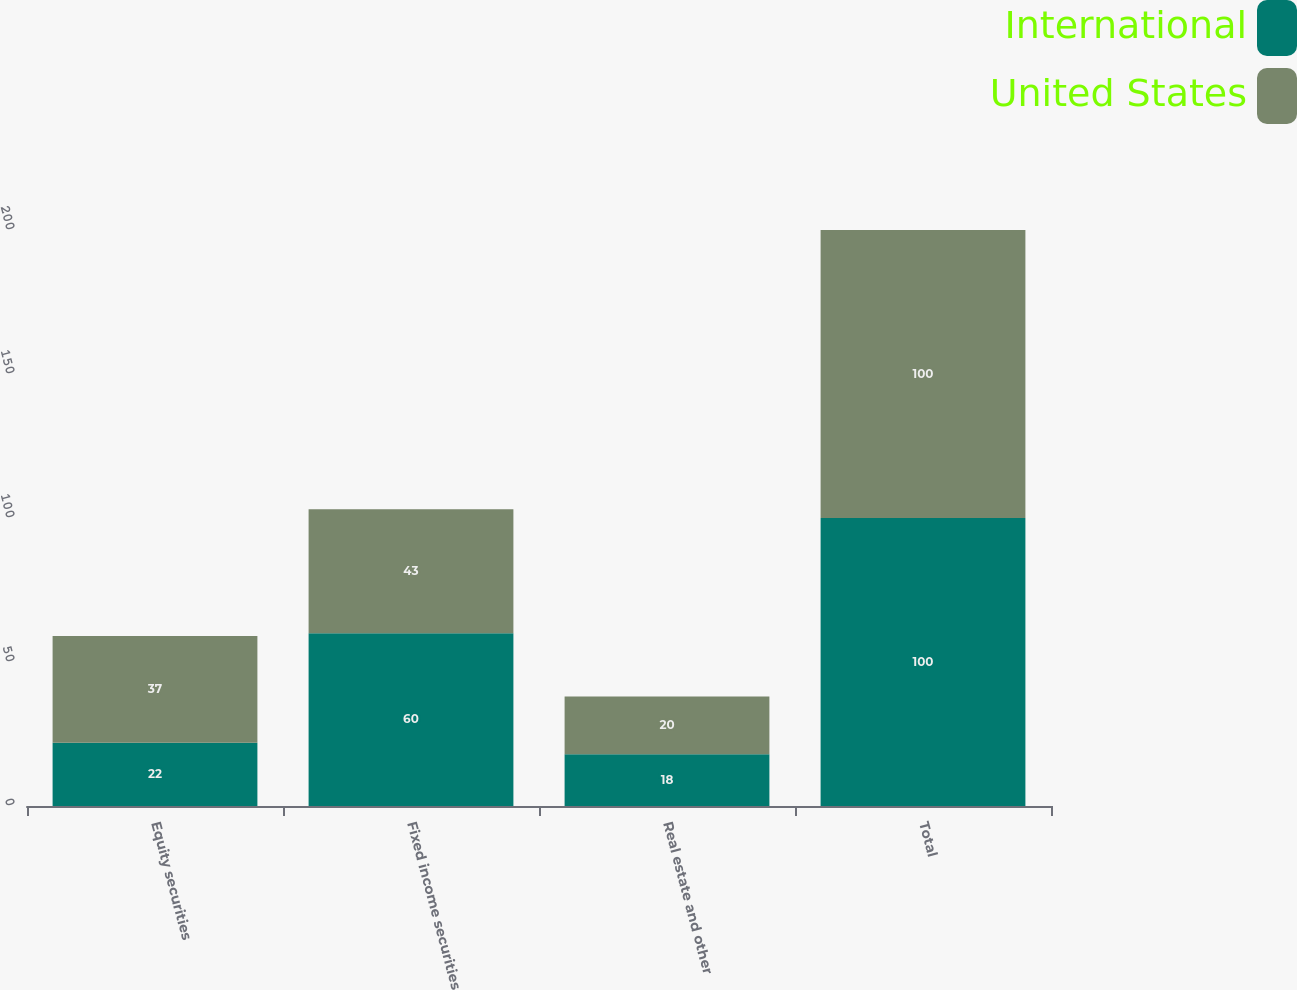Convert chart to OTSL. <chart><loc_0><loc_0><loc_500><loc_500><stacked_bar_chart><ecel><fcel>Equity securities<fcel>Fixed income securities<fcel>Real estate and other<fcel>Total<nl><fcel>International<fcel>22<fcel>60<fcel>18<fcel>100<nl><fcel>United States<fcel>37<fcel>43<fcel>20<fcel>100<nl></chart> 